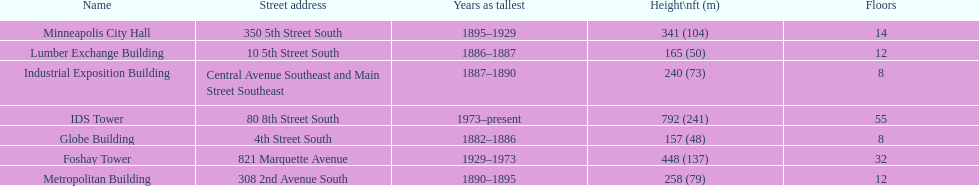Name the tallest building. IDS Tower. 